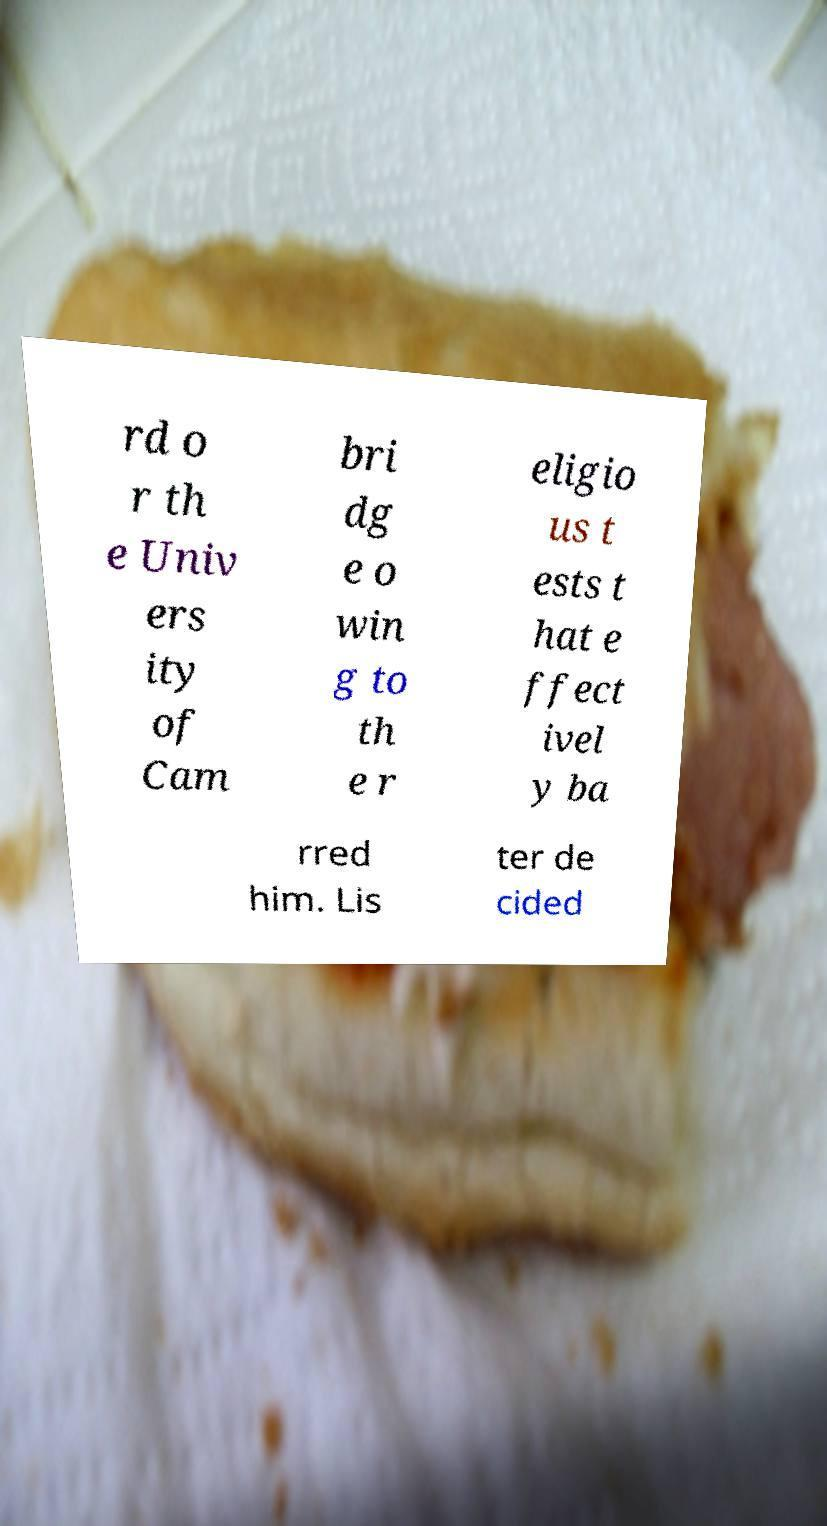What messages or text are displayed in this image? I need them in a readable, typed format. rd o r th e Univ ers ity of Cam bri dg e o win g to th e r eligio us t ests t hat e ffect ivel y ba rred him. Lis ter de cided 